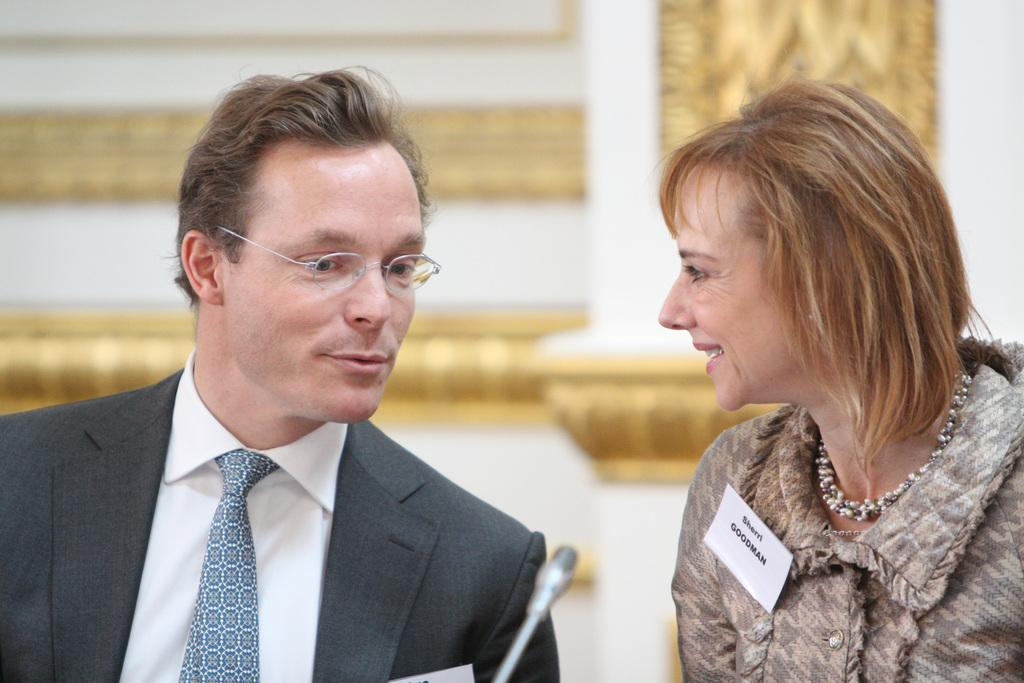How many people are present in the image? There are two people in the image. What object is located at the bottom of the image? There is a microphone at the bottom of the image. What can be seen in the background of the image? There is a wall in the background of the image. How many bikes are parked against the wall in the image? There are no bikes present in the image; only two people and a microphone are visible. 